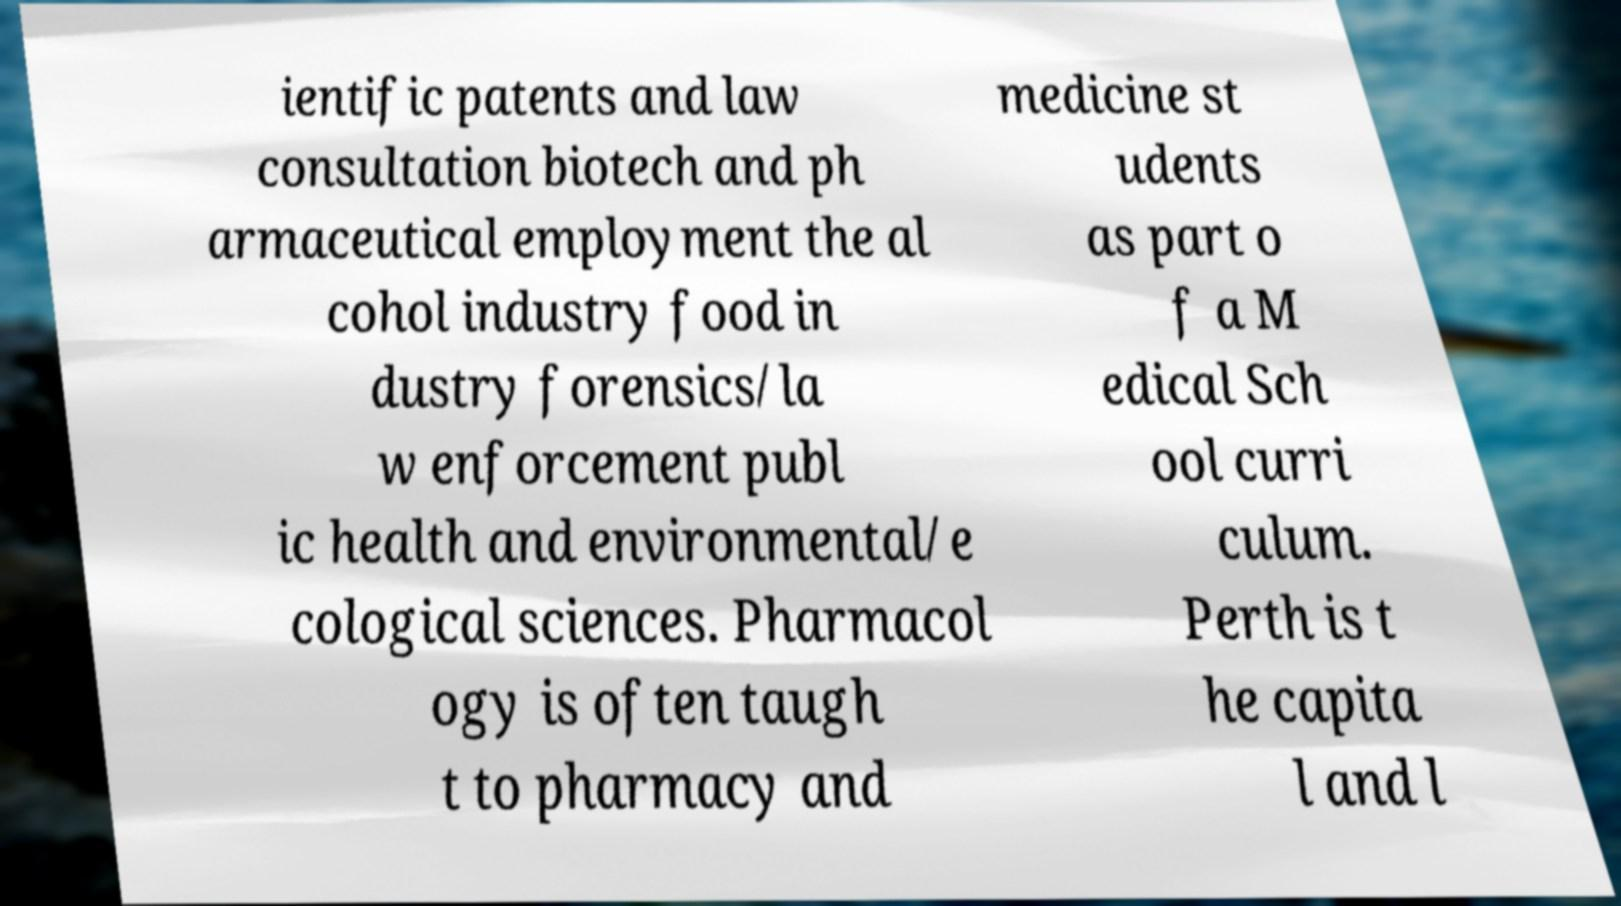Can you accurately transcribe the text from the provided image for me? ientific patents and law consultation biotech and ph armaceutical employment the al cohol industry food in dustry forensics/la w enforcement publ ic health and environmental/e cological sciences. Pharmacol ogy is often taugh t to pharmacy and medicine st udents as part o f a M edical Sch ool curri culum. Perth is t he capita l and l 